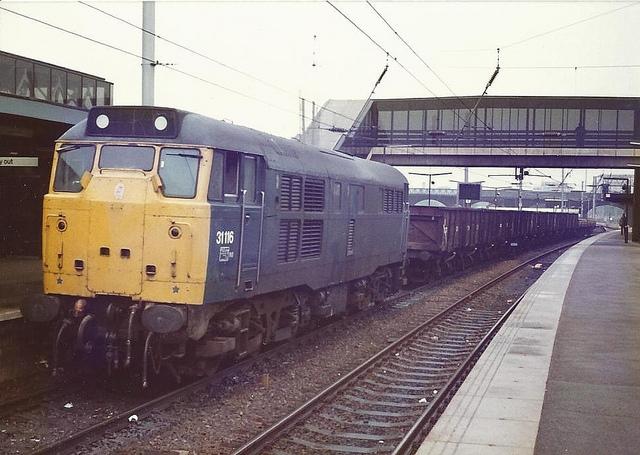What color is the front of the train?
Quick response, please. Yellow. Is the train new?
Answer briefly. No. Is there a train?
Quick response, please. Yes. How many tracks are there?
Be succinct. 2. 